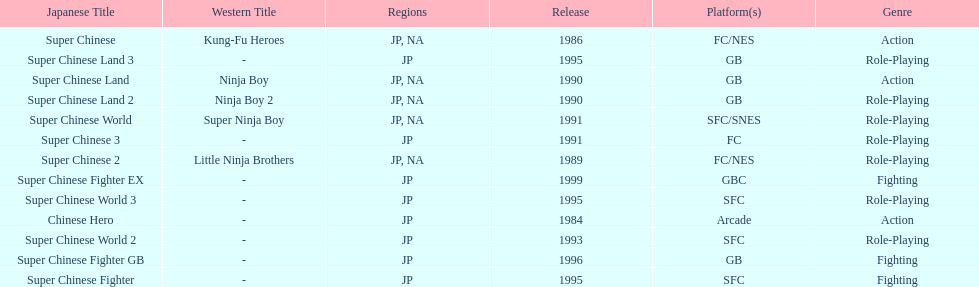What are the total of super chinese games released? 13. 